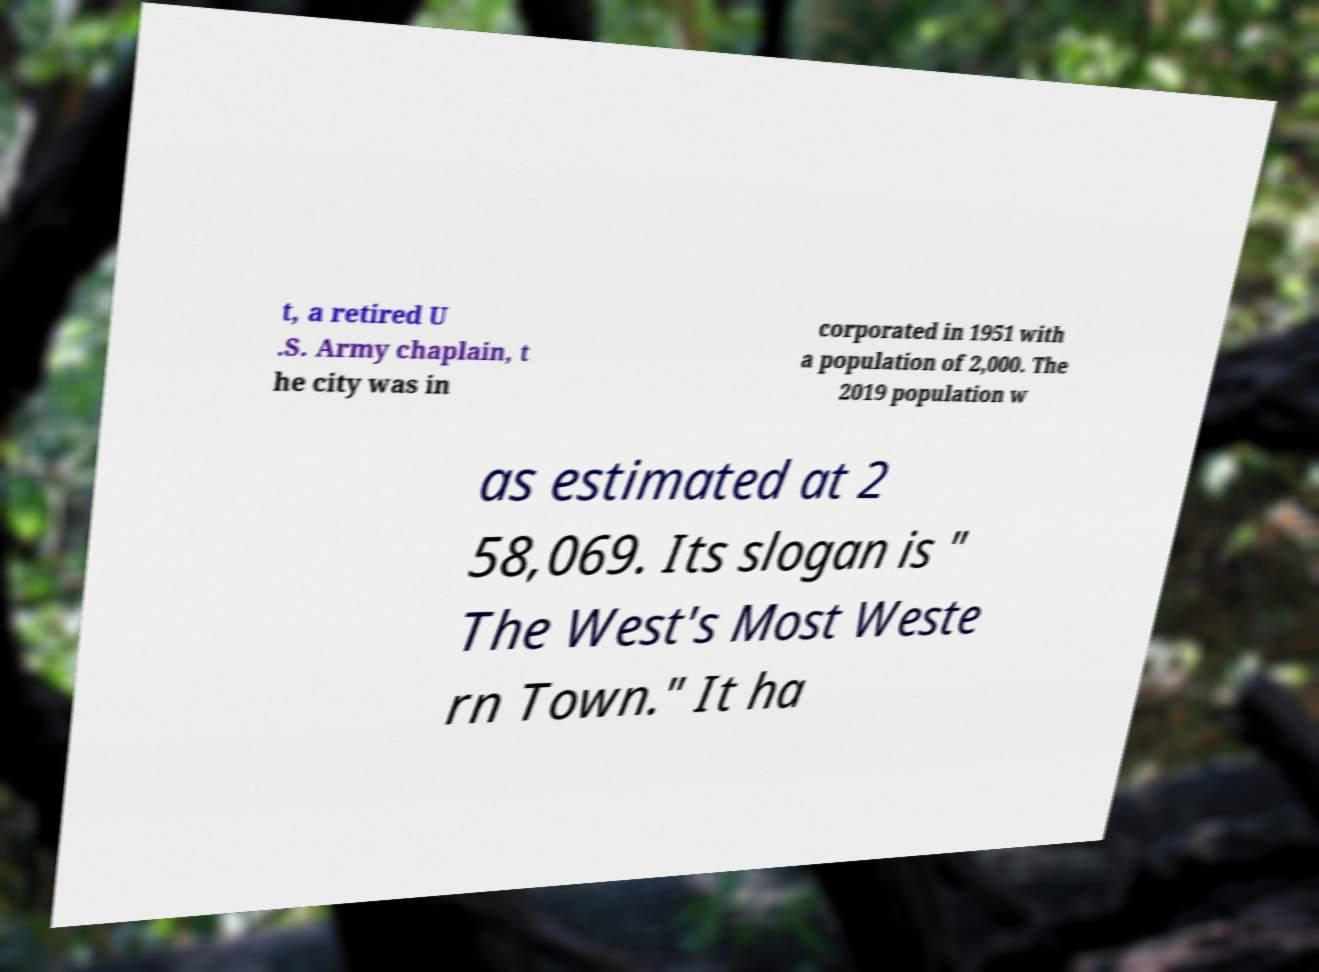I need the written content from this picture converted into text. Can you do that? t, a retired U .S. Army chaplain, t he city was in corporated in 1951 with a population of 2,000. The 2019 population w as estimated at 2 58,069. Its slogan is " The West's Most Weste rn Town." It ha 